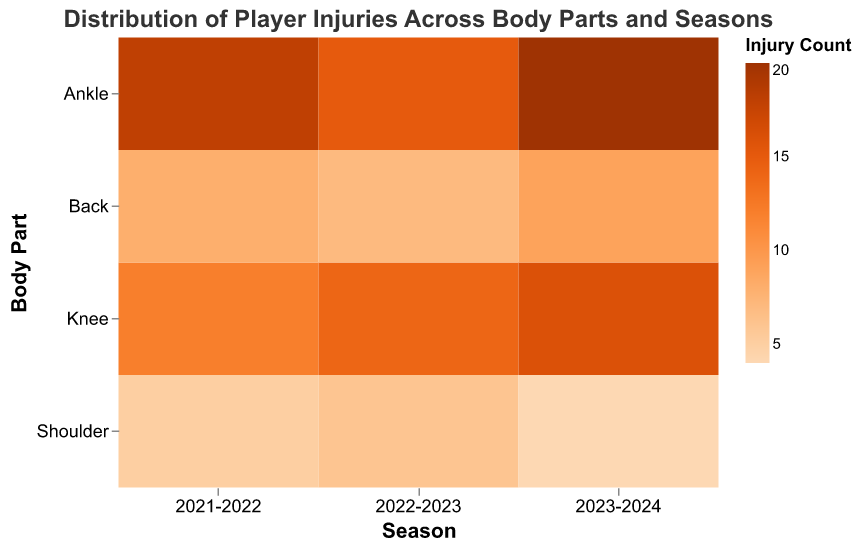What is the title of the mosaic plot? The title of the plot is usually located at the top and it describes what the plot is about. It helps provide context for the data being visualized. In this case, the title states the overall content and focus of the mosaic plot.
Answer: Distribution of Player Injuries Across Body Parts and Seasons How many seasons are displayed in the figure? The x-axis represents the seasons. By counting the number of ticks or labels along the x-axis, we can determine the number of seasons included in the plot.
Answer: 3 Which body part had the highest number of injuries in the 2023-2024 season? By looking at the intersection of the 2023-2024 season on the x-axis and the body parts on the y-axis, we can identify the rect corresponding to each body part. The body part with the darkest shade of orange indicates the highest value.
Answer: Ankle Is the number of knee injuries increasing or decreasing over the seasons? To determine if there's an increasing or decreasing trend, we look at the shades of orange along the row for the knee as we move from left to right across the seasons. A trend towards darker shades indicates an increase, while lighter shades indicate a decrease.
Answer: Increasing Which season had the lowest number of back injuries? We identify the row corresponding to "Back" and compare the shades of orange for each season. The season with the lightest shade of orange indicates the lowest number.
Answer: 2022-2023 What is the combined number of shoulder injuries for all seasons? By summing the numbers of shoulder injuries from each season, we can get the total. From the data: 5 (2021-2022) + 6 (2022-2023) + 4 (2023-2024).
Answer: 15 In which season was the distribution of injuries across different body parts the most balanced? A balanced distribution would mean relatively even shades of orange across all body parts for a given season. Compare the variance in shades for each season to identify the most balanced one.
Answer: 2022-2023 Which body part showed a consistent increase in injuries over the three seasons? For each body part, track the change in the shade of orange from the 2021-2022 season to the 2023-2024 season. Consistent darkening of the shade means an increase in injuries.
Answer: Ankle What is the total number of injuries recorded in the 2021-2022 season? By summing the counts of injuries for each body part within the 2021-2022 season, we can get the total. From the data: 18 (Ankle) + 12 (Knee) + 8 (Back) + 5 (Shoulder).
Answer: 43 